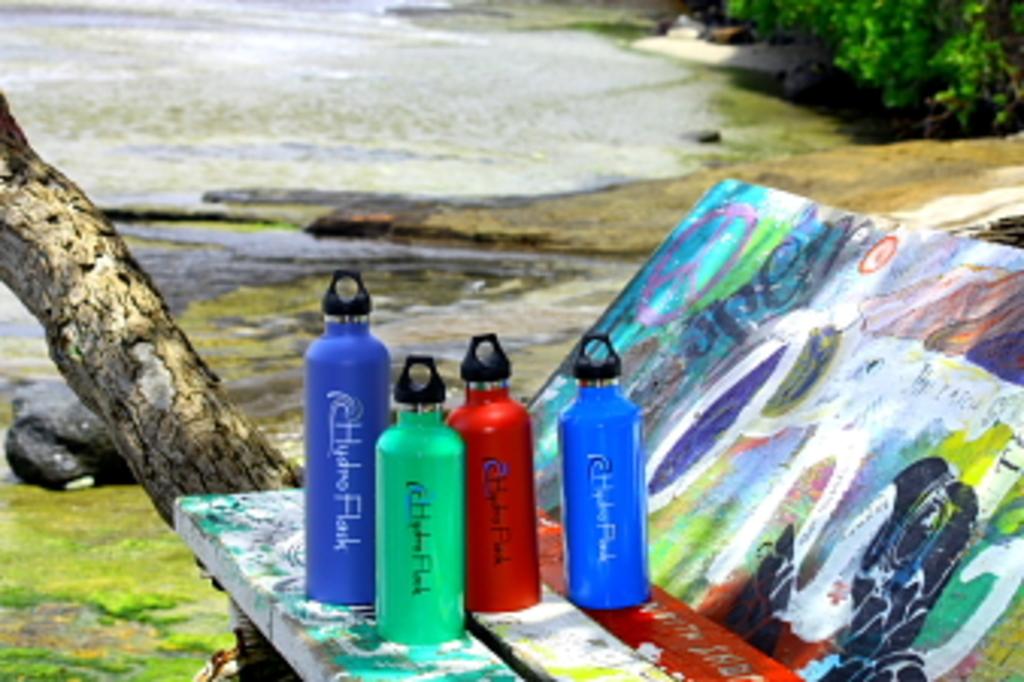How many water bottles are there?
Make the answer very short. 4. 